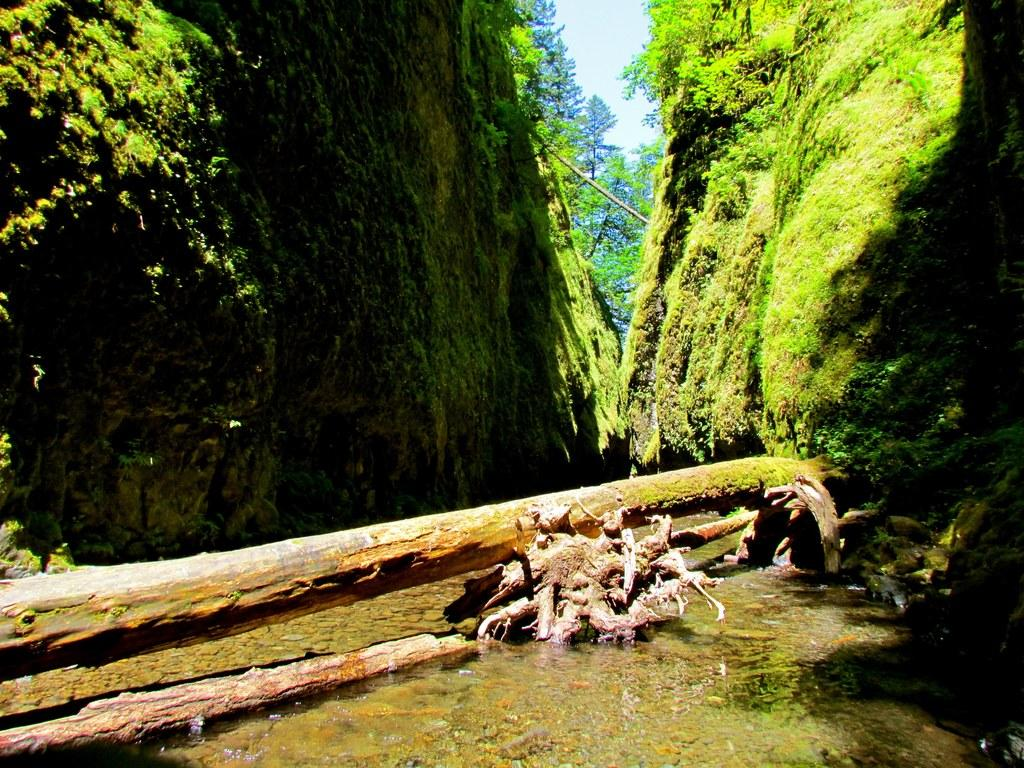What is the primary element visible in the image? There is water in the image. What else can be seen in the image besides water? There are tree trunks and grass on the rocks in the image. What is visible in the background of the image? There are trees and the sky in the background of the image. How many trees are providing shade for the water in the image? There is no mention of trees providing shade for the water in the image. 